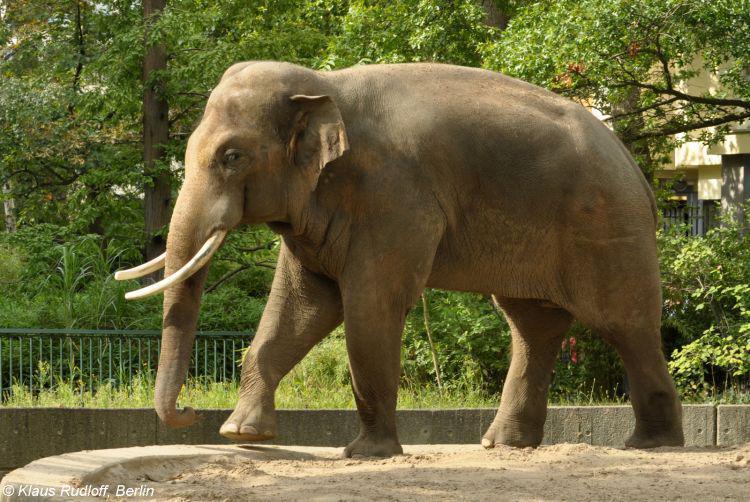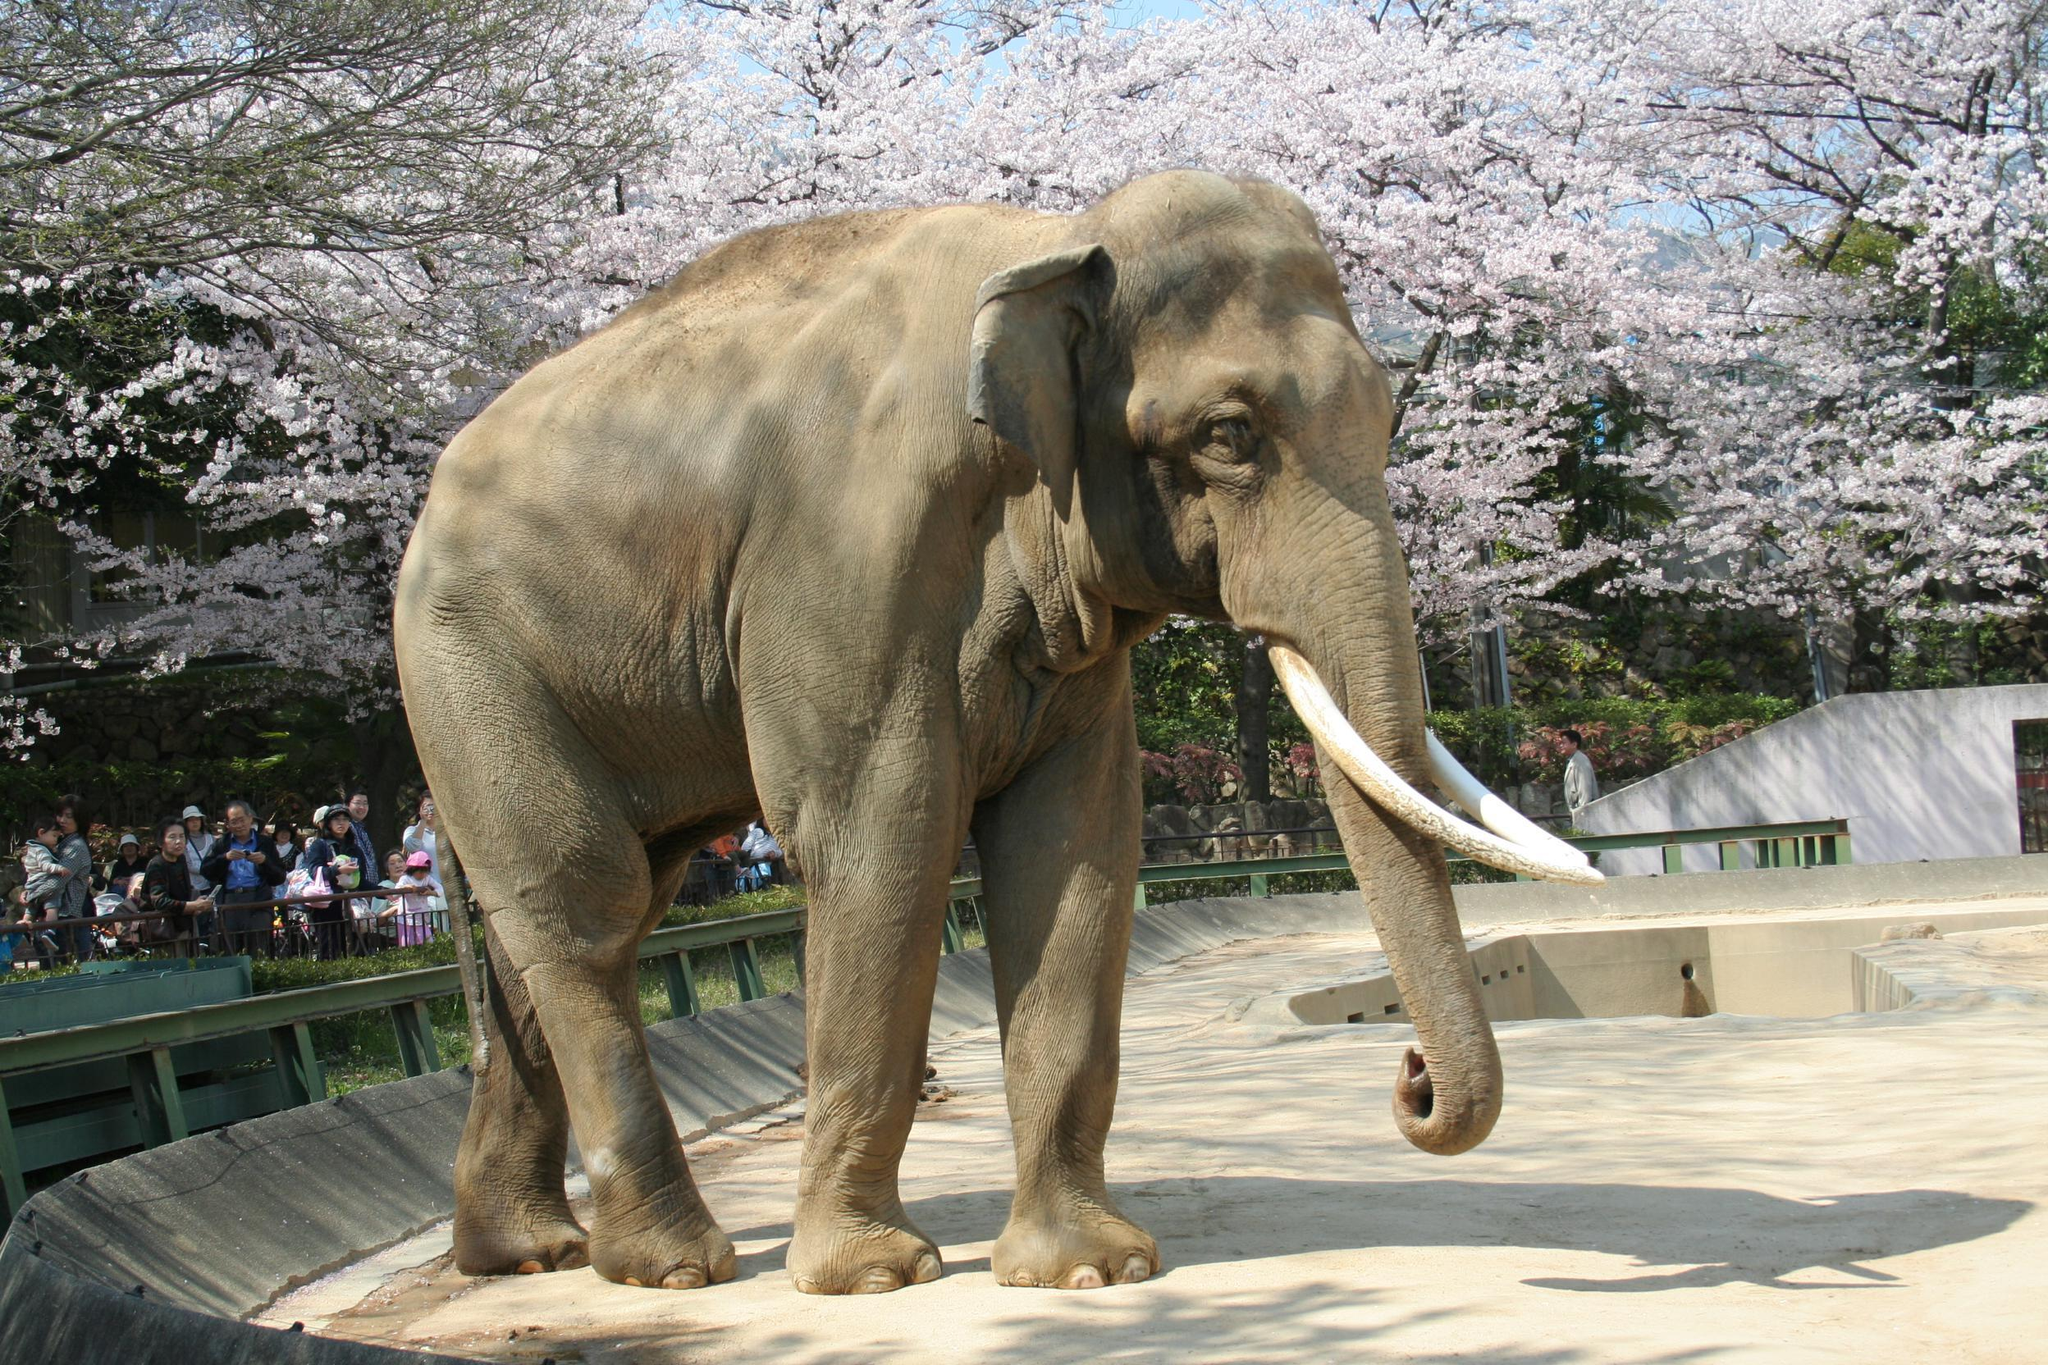The first image is the image on the left, the second image is the image on the right. Assess this claim about the two images: "The right image contains exactly one elephant.". Correct or not? Answer yes or no. Yes. The first image is the image on the left, the second image is the image on the right. Given the left and right images, does the statement "There are two elephanfs in the image pair." hold true? Answer yes or no. Yes. 